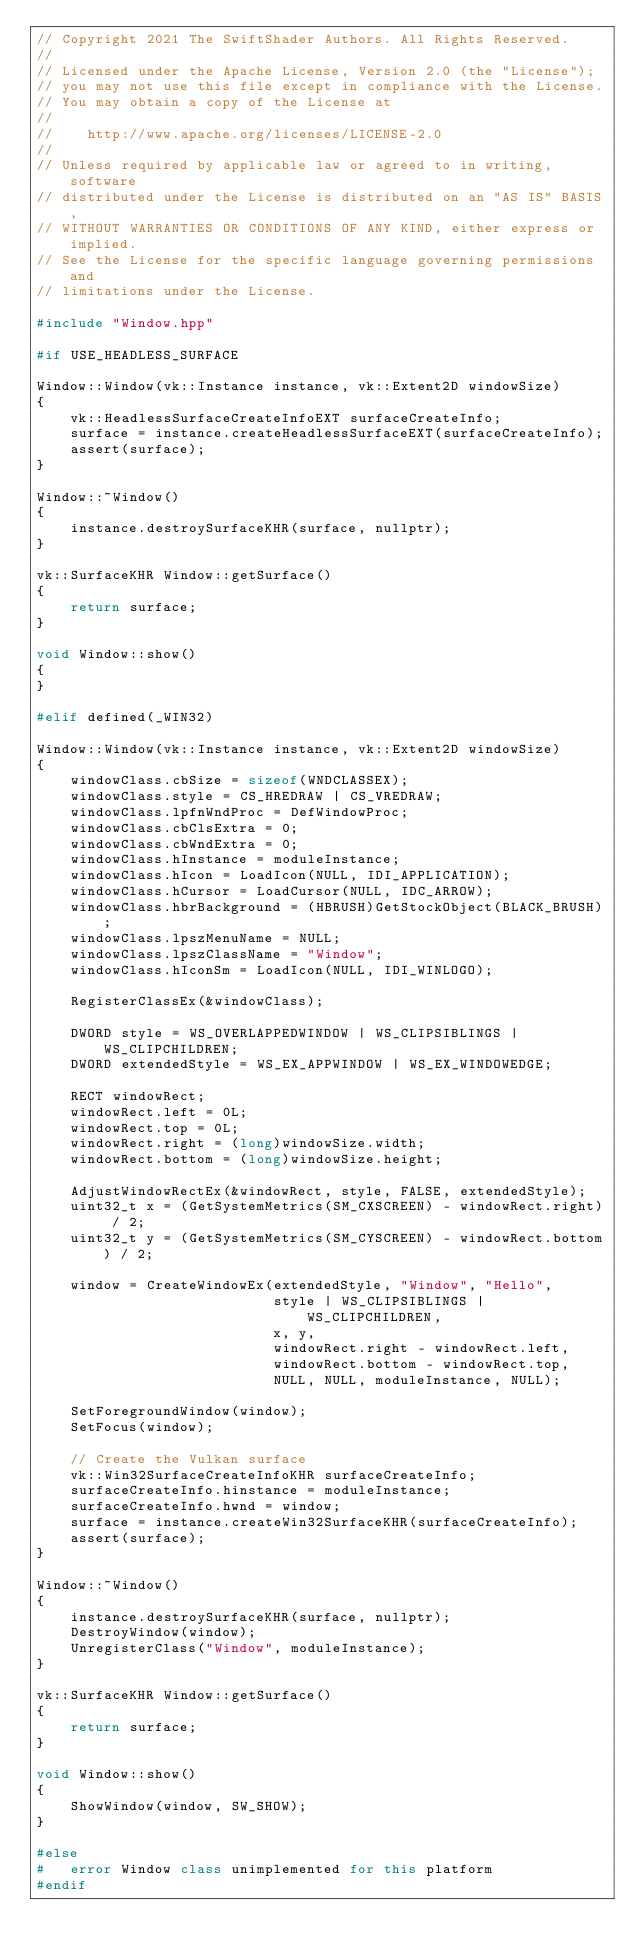Convert code to text. <code><loc_0><loc_0><loc_500><loc_500><_C++_>// Copyright 2021 The SwiftShader Authors. All Rights Reserved.
//
// Licensed under the Apache License, Version 2.0 (the "License");
// you may not use this file except in compliance with the License.
// You may obtain a copy of the License at
//
//    http://www.apache.org/licenses/LICENSE-2.0
//
// Unless required by applicable law or agreed to in writing, software
// distributed under the License is distributed on an "AS IS" BASIS,
// WITHOUT WARRANTIES OR CONDITIONS OF ANY KIND, either express or implied.
// See the License for the specific language governing permissions and
// limitations under the License.

#include "Window.hpp"

#if USE_HEADLESS_SURFACE

Window::Window(vk::Instance instance, vk::Extent2D windowSize)
{
	vk::HeadlessSurfaceCreateInfoEXT surfaceCreateInfo;
	surface = instance.createHeadlessSurfaceEXT(surfaceCreateInfo);
	assert(surface);
}

Window::~Window()
{
	instance.destroySurfaceKHR(surface, nullptr);
}

vk::SurfaceKHR Window::getSurface()
{
	return surface;
}

void Window::show()
{
}

#elif defined(_WIN32)

Window::Window(vk::Instance instance, vk::Extent2D windowSize)
{
	windowClass.cbSize = sizeof(WNDCLASSEX);
	windowClass.style = CS_HREDRAW | CS_VREDRAW;
	windowClass.lpfnWndProc = DefWindowProc;
	windowClass.cbClsExtra = 0;
	windowClass.cbWndExtra = 0;
	windowClass.hInstance = moduleInstance;
	windowClass.hIcon = LoadIcon(NULL, IDI_APPLICATION);
	windowClass.hCursor = LoadCursor(NULL, IDC_ARROW);
	windowClass.hbrBackground = (HBRUSH)GetStockObject(BLACK_BRUSH);
	windowClass.lpszMenuName = NULL;
	windowClass.lpszClassName = "Window";
	windowClass.hIconSm = LoadIcon(NULL, IDI_WINLOGO);

	RegisterClassEx(&windowClass);

	DWORD style = WS_OVERLAPPEDWINDOW | WS_CLIPSIBLINGS | WS_CLIPCHILDREN;
	DWORD extendedStyle = WS_EX_APPWINDOW | WS_EX_WINDOWEDGE;

	RECT windowRect;
	windowRect.left = 0L;
	windowRect.top = 0L;
	windowRect.right = (long)windowSize.width;
	windowRect.bottom = (long)windowSize.height;

	AdjustWindowRectEx(&windowRect, style, FALSE, extendedStyle);
	uint32_t x = (GetSystemMetrics(SM_CXSCREEN) - windowRect.right) / 2;
	uint32_t y = (GetSystemMetrics(SM_CYSCREEN) - windowRect.bottom) / 2;

	window = CreateWindowEx(extendedStyle, "Window", "Hello",
	                        style | WS_CLIPSIBLINGS | WS_CLIPCHILDREN,
	                        x, y,
	                        windowRect.right - windowRect.left,
	                        windowRect.bottom - windowRect.top,
	                        NULL, NULL, moduleInstance, NULL);

	SetForegroundWindow(window);
	SetFocus(window);

	// Create the Vulkan surface
	vk::Win32SurfaceCreateInfoKHR surfaceCreateInfo;
	surfaceCreateInfo.hinstance = moduleInstance;
	surfaceCreateInfo.hwnd = window;
	surface = instance.createWin32SurfaceKHR(surfaceCreateInfo);
	assert(surface);
}

Window::~Window()
{
	instance.destroySurfaceKHR(surface, nullptr);
	DestroyWindow(window);
	UnregisterClass("Window", moduleInstance);
}

vk::SurfaceKHR Window::getSurface()
{
	return surface;
}

void Window::show()
{
	ShowWindow(window, SW_SHOW);
}

#else
#	error Window class unimplemented for this platform
#endif
</code> 